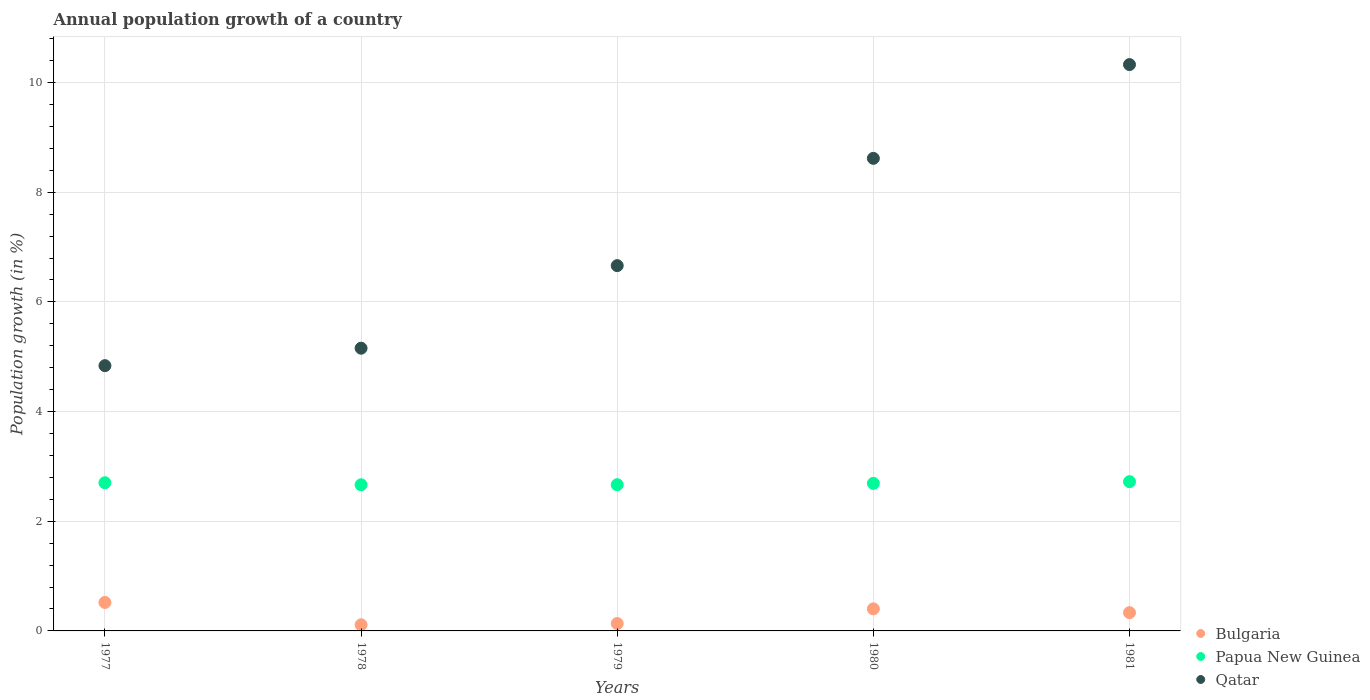Is the number of dotlines equal to the number of legend labels?
Ensure brevity in your answer.  Yes. What is the annual population growth in Qatar in 1979?
Your response must be concise. 6.66. Across all years, what is the maximum annual population growth in Papua New Guinea?
Provide a short and direct response. 2.72. Across all years, what is the minimum annual population growth in Bulgaria?
Ensure brevity in your answer.  0.11. In which year was the annual population growth in Papua New Guinea minimum?
Your answer should be compact. 1978. What is the total annual population growth in Bulgaria in the graph?
Your answer should be very brief. 1.5. What is the difference between the annual population growth in Qatar in 1977 and that in 1978?
Provide a succinct answer. -0.32. What is the difference between the annual population growth in Papua New Guinea in 1981 and the annual population growth in Bulgaria in 1977?
Your answer should be very brief. 2.2. What is the average annual population growth in Papua New Guinea per year?
Make the answer very short. 2.69. In the year 1979, what is the difference between the annual population growth in Papua New Guinea and annual population growth in Bulgaria?
Ensure brevity in your answer.  2.53. What is the ratio of the annual population growth in Papua New Guinea in 1978 to that in 1981?
Your answer should be very brief. 0.98. Is the difference between the annual population growth in Papua New Guinea in 1977 and 1979 greater than the difference between the annual population growth in Bulgaria in 1977 and 1979?
Your answer should be compact. No. What is the difference between the highest and the second highest annual population growth in Papua New Guinea?
Offer a very short reply. 0.02. What is the difference between the highest and the lowest annual population growth in Bulgaria?
Make the answer very short. 0.41. Is the sum of the annual population growth in Qatar in 1978 and 1979 greater than the maximum annual population growth in Bulgaria across all years?
Provide a short and direct response. Yes. Does the annual population growth in Bulgaria monotonically increase over the years?
Offer a very short reply. No. Is the annual population growth in Qatar strictly greater than the annual population growth in Bulgaria over the years?
Your response must be concise. Yes. Is the annual population growth in Qatar strictly less than the annual population growth in Papua New Guinea over the years?
Your answer should be compact. No. How many years are there in the graph?
Your answer should be compact. 5. Are the values on the major ticks of Y-axis written in scientific E-notation?
Provide a short and direct response. No. Does the graph contain any zero values?
Provide a succinct answer. No. Does the graph contain grids?
Provide a short and direct response. Yes. Where does the legend appear in the graph?
Keep it short and to the point. Bottom right. How are the legend labels stacked?
Offer a terse response. Vertical. What is the title of the graph?
Make the answer very short. Annual population growth of a country. Does "Mexico" appear as one of the legend labels in the graph?
Offer a very short reply. No. What is the label or title of the Y-axis?
Your answer should be very brief. Population growth (in %). What is the Population growth (in %) in Bulgaria in 1977?
Your answer should be very brief. 0.52. What is the Population growth (in %) of Papua New Guinea in 1977?
Provide a succinct answer. 2.7. What is the Population growth (in %) in Qatar in 1977?
Provide a short and direct response. 4.84. What is the Population growth (in %) of Bulgaria in 1978?
Your answer should be very brief. 0.11. What is the Population growth (in %) in Papua New Guinea in 1978?
Offer a very short reply. 2.66. What is the Population growth (in %) in Qatar in 1978?
Your response must be concise. 5.16. What is the Population growth (in %) of Bulgaria in 1979?
Your response must be concise. 0.14. What is the Population growth (in %) in Papua New Guinea in 1979?
Ensure brevity in your answer.  2.67. What is the Population growth (in %) of Qatar in 1979?
Offer a terse response. 6.66. What is the Population growth (in %) of Bulgaria in 1980?
Provide a short and direct response. 0.4. What is the Population growth (in %) in Papua New Guinea in 1980?
Your response must be concise. 2.69. What is the Population growth (in %) in Qatar in 1980?
Give a very brief answer. 8.62. What is the Population growth (in %) in Bulgaria in 1981?
Keep it short and to the point. 0.33. What is the Population growth (in %) in Papua New Guinea in 1981?
Offer a terse response. 2.72. What is the Population growth (in %) in Qatar in 1981?
Your answer should be compact. 10.33. Across all years, what is the maximum Population growth (in %) in Bulgaria?
Your answer should be very brief. 0.52. Across all years, what is the maximum Population growth (in %) in Papua New Guinea?
Offer a very short reply. 2.72. Across all years, what is the maximum Population growth (in %) of Qatar?
Offer a terse response. 10.33. Across all years, what is the minimum Population growth (in %) in Bulgaria?
Give a very brief answer. 0.11. Across all years, what is the minimum Population growth (in %) of Papua New Guinea?
Give a very brief answer. 2.66. Across all years, what is the minimum Population growth (in %) in Qatar?
Your answer should be compact. 4.84. What is the total Population growth (in %) in Bulgaria in the graph?
Offer a very short reply. 1.5. What is the total Population growth (in %) in Papua New Guinea in the graph?
Offer a terse response. 13.45. What is the total Population growth (in %) of Qatar in the graph?
Provide a succinct answer. 35.6. What is the difference between the Population growth (in %) of Bulgaria in 1977 and that in 1978?
Your response must be concise. 0.41. What is the difference between the Population growth (in %) in Papua New Guinea in 1977 and that in 1978?
Provide a succinct answer. 0.04. What is the difference between the Population growth (in %) of Qatar in 1977 and that in 1978?
Ensure brevity in your answer.  -0.32. What is the difference between the Population growth (in %) of Bulgaria in 1977 and that in 1979?
Your answer should be very brief. 0.38. What is the difference between the Population growth (in %) of Papua New Guinea in 1977 and that in 1979?
Make the answer very short. 0.04. What is the difference between the Population growth (in %) in Qatar in 1977 and that in 1979?
Offer a terse response. -1.82. What is the difference between the Population growth (in %) in Bulgaria in 1977 and that in 1980?
Keep it short and to the point. 0.12. What is the difference between the Population growth (in %) of Papua New Guinea in 1977 and that in 1980?
Provide a succinct answer. 0.01. What is the difference between the Population growth (in %) in Qatar in 1977 and that in 1980?
Make the answer very short. -3.78. What is the difference between the Population growth (in %) of Bulgaria in 1977 and that in 1981?
Give a very brief answer. 0.19. What is the difference between the Population growth (in %) of Papua New Guinea in 1977 and that in 1981?
Your answer should be very brief. -0.02. What is the difference between the Population growth (in %) of Qatar in 1977 and that in 1981?
Your answer should be compact. -5.49. What is the difference between the Population growth (in %) of Bulgaria in 1978 and that in 1979?
Your response must be concise. -0.02. What is the difference between the Population growth (in %) in Papua New Guinea in 1978 and that in 1979?
Ensure brevity in your answer.  -0. What is the difference between the Population growth (in %) of Qatar in 1978 and that in 1979?
Ensure brevity in your answer.  -1.51. What is the difference between the Population growth (in %) of Bulgaria in 1978 and that in 1980?
Offer a terse response. -0.29. What is the difference between the Population growth (in %) in Papua New Guinea in 1978 and that in 1980?
Keep it short and to the point. -0.03. What is the difference between the Population growth (in %) of Qatar in 1978 and that in 1980?
Provide a succinct answer. -3.46. What is the difference between the Population growth (in %) in Bulgaria in 1978 and that in 1981?
Your response must be concise. -0.22. What is the difference between the Population growth (in %) of Papua New Guinea in 1978 and that in 1981?
Your answer should be compact. -0.06. What is the difference between the Population growth (in %) of Qatar in 1978 and that in 1981?
Your answer should be very brief. -5.17. What is the difference between the Population growth (in %) of Bulgaria in 1979 and that in 1980?
Provide a succinct answer. -0.27. What is the difference between the Population growth (in %) in Papua New Guinea in 1979 and that in 1980?
Make the answer very short. -0.02. What is the difference between the Population growth (in %) in Qatar in 1979 and that in 1980?
Give a very brief answer. -1.96. What is the difference between the Population growth (in %) of Bulgaria in 1979 and that in 1981?
Make the answer very short. -0.2. What is the difference between the Population growth (in %) of Papua New Guinea in 1979 and that in 1981?
Your response must be concise. -0.06. What is the difference between the Population growth (in %) in Qatar in 1979 and that in 1981?
Provide a succinct answer. -3.67. What is the difference between the Population growth (in %) of Bulgaria in 1980 and that in 1981?
Provide a succinct answer. 0.07. What is the difference between the Population growth (in %) in Papua New Guinea in 1980 and that in 1981?
Provide a short and direct response. -0.03. What is the difference between the Population growth (in %) in Qatar in 1980 and that in 1981?
Your answer should be very brief. -1.71. What is the difference between the Population growth (in %) of Bulgaria in 1977 and the Population growth (in %) of Papua New Guinea in 1978?
Your response must be concise. -2.15. What is the difference between the Population growth (in %) of Bulgaria in 1977 and the Population growth (in %) of Qatar in 1978?
Your response must be concise. -4.64. What is the difference between the Population growth (in %) of Papua New Guinea in 1977 and the Population growth (in %) of Qatar in 1978?
Provide a short and direct response. -2.45. What is the difference between the Population growth (in %) in Bulgaria in 1977 and the Population growth (in %) in Papua New Guinea in 1979?
Your answer should be very brief. -2.15. What is the difference between the Population growth (in %) of Bulgaria in 1977 and the Population growth (in %) of Qatar in 1979?
Keep it short and to the point. -6.14. What is the difference between the Population growth (in %) in Papua New Guinea in 1977 and the Population growth (in %) in Qatar in 1979?
Make the answer very short. -3.96. What is the difference between the Population growth (in %) of Bulgaria in 1977 and the Population growth (in %) of Papua New Guinea in 1980?
Give a very brief answer. -2.17. What is the difference between the Population growth (in %) of Bulgaria in 1977 and the Population growth (in %) of Qatar in 1980?
Keep it short and to the point. -8.1. What is the difference between the Population growth (in %) in Papua New Guinea in 1977 and the Population growth (in %) in Qatar in 1980?
Offer a terse response. -5.92. What is the difference between the Population growth (in %) of Bulgaria in 1977 and the Population growth (in %) of Papua New Guinea in 1981?
Provide a succinct answer. -2.2. What is the difference between the Population growth (in %) in Bulgaria in 1977 and the Population growth (in %) in Qatar in 1981?
Make the answer very short. -9.81. What is the difference between the Population growth (in %) of Papua New Guinea in 1977 and the Population growth (in %) of Qatar in 1981?
Give a very brief answer. -7.62. What is the difference between the Population growth (in %) of Bulgaria in 1978 and the Population growth (in %) of Papua New Guinea in 1979?
Provide a short and direct response. -2.55. What is the difference between the Population growth (in %) in Bulgaria in 1978 and the Population growth (in %) in Qatar in 1979?
Make the answer very short. -6.55. What is the difference between the Population growth (in %) in Papua New Guinea in 1978 and the Population growth (in %) in Qatar in 1979?
Your answer should be very brief. -4. What is the difference between the Population growth (in %) of Bulgaria in 1978 and the Population growth (in %) of Papua New Guinea in 1980?
Your answer should be very brief. -2.58. What is the difference between the Population growth (in %) in Bulgaria in 1978 and the Population growth (in %) in Qatar in 1980?
Make the answer very short. -8.51. What is the difference between the Population growth (in %) in Papua New Guinea in 1978 and the Population growth (in %) in Qatar in 1980?
Give a very brief answer. -5.95. What is the difference between the Population growth (in %) of Bulgaria in 1978 and the Population growth (in %) of Papua New Guinea in 1981?
Your response must be concise. -2.61. What is the difference between the Population growth (in %) in Bulgaria in 1978 and the Population growth (in %) in Qatar in 1981?
Give a very brief answer. -10.22. What is the difference between the Population growth (in %) of Papua New Guinea in 1978 and the Population growth (in %) of Qatar in 1981?
Your answer should be compact. -7.66. What is the difference between the Population growth (in %) of Bulgaria in 1979 and the Population growth (in %) of Papua New Guinea in 1980?
Offer a terse response. -2.56. What is the difference between the Population growth (in %) of Bulgaria in 1979 and the Population growth (in %) of Qatar in 1980?
Keep it short and to the point. -8.48. What is the difference between the Population growth (in %) in Papua New Guinea in 1979 and the Population growth (in %) in Qatar in 1980?
Your response must be concise. -5.95. What is the difference between the Population growth (in %) in Bulgaria in 1979 and the Population growth (in %) in Papua New Guinea in 1981?
Your response must be concise. -2.59. What is the difference between the Population growth (in %) of Bulgaria in 1979 and the Population growth (in %) of Qatar in 1981?
Give a very brief answer. -10.19. What is the difference between the Population growth (in %) of Papua New Guinea in 1979 and the Population growth (in %) of Qatar in 1981?
Your answer should be compact. -7.66. What is the difference between the Population growth (in %) of Bulgaria in 1980 and the Population growth (in %) of Papua New Guinea in 1981?
Your answer should be compact. -2.32. What is the difference between the Population growth (in %) of Bulgaria in 1980 and the Population growth (in %) of Qatar in 1981?
Provide a succinct answer. -9.92. What is the difference between the Population growth (in %) of Papua New Guinea in 1980 and the Population growth (in %) of Qatar in 1981?
Provide a short and direct response. -7.64. What is the average Population growth (in %) of Bulgaria per year?
Give a very brief answer. 0.3. What is the average Population growth (in %) in Papua New Guinea per year?
Provide a succinct answer. 2.69. What is the average Population growth (in %) of Qatar per year?
Offer a terse response. 7.12. In the year 1977, what is the difference between the Population growth (in %) in Bulgaria and Population growth (in %) in Papua New Guinea?
Provide a succinct answer. -2.18. In the year 1977, what is the difference between the Population growth (in %) in Bulgaria and Population growth (in %) in Qatar?
Provide a short and direct response. -4.32. In the year 1977, what is the difference between the Population growth (in %) of Papua New Guinea and Population growth (in %) of Qatar?
Give a very brief answer. -2.13. In the year 1978, what is the difference between the Population growth (in %) of Bulgaria and Population growth (in %) of Papua New Guinea?
Give a very brief answer. -2.55. In the year 1978, what is the difference between the Population growth (in %) in Bulgaria and Population growth (in %) in Qatar?
Ensure brevity in your answer.  -5.04. In the year 1978, what is the difference between the Population growth (in %) in Papua New Guinea and Population growth (in %) in Qatar?
Give a very brief answer. -2.49. In the year 1979, what is the difference between the Population growth (in %) of Bulgaria and Population growth (in %) of Papua New Guinea?
Keep it short and to the point. -2.53. In the year 1979, what is the difference between the Population growth (in %) of Bulgaria and Population growth (in %) of Qatar?
Give a very brief answer. -6.53. In the year 1979, what is the difference between the Population growth (in %) in Papua New Guinea and Population growth (in %) in Qatar?
Your answer should be compact. -3.99. In the year 1980, what is the difference between the Population growth (in %) in Bulgaria and Population growth (in %) in Papua New Guinea?
Offer a very short reply. -2.29. In the year 1980, what is the difference between the Population growth (in %) in Bulgaria and Population growth (in %) in Qatar?
Your answer should be very brief. -8.21. In the year 1980, what is the difference between the Population growth (in %) in Papua New Guinea and Population growth (in %) in Qatar?
Offer a terse response. -5.93. In the year 1981, what is the difference between the Population growth (in %) in Bulgaria and Population growth (in %) in Papua New Guinea?
Offer a very short reply. -2.39. In the year 1981, what is the difference between the Population growth (in %) of Bulgaria and Population growth (in %) of Qatar?
Provide a succinct answer. -9.99. In the year 1981, what is the difference between the Population growth (in %) of Papua New Guinea and Population growth (in %) of Qatar?
Your answer should be very brief. -7.61. What is the ratio of the Population growth (in %) of Bulgaria in 1977 to that in 1978?
Your response must be concise. 4.64. What is the ratio of the Population growth (in %) of Papua New Guinea in 1977 to that in 1978?
Offer a very short reply. 1.01. What is the ratio of the Population growth (in %) in Qatar in 1977 to that in 1978?
Your response must be concise. 0.94. What is the ratio of the Population growth (in %) in Bulgaria in 1977 to that in 1979?
Provide a succinct answer. 3.84. What is the ratio of the Population growth (in %) in Papua New Guinea in 1977 to that in 1979?
Your response must be concise. 1.01. What is the ratio of the Population growth (in %) in Qatar in 1977 to that in 1979?
Keep it short and to the point. 0.73. What is the ratio of the Population growth (in %) in Bulgaria in 1977 to that in 1980?
Provide a short and direct response. 1.29. What is the ratio of the Population growth (in %) in Qatar in 1977 to that in 1980?
Provide a succinct answer. 0.56. What is the ratio of the Population growth (in %) of Bulgaria in 1977 to that in 1981?
Offer a very short reply. 1.56. What is the ratio of the Population growth (in %) in Papua New Guinea in 1977 to that in 1981?
Give a very brief answer. 0.99. What is the ratio of the Population growth (in %) in Qatar in 1977 to that in 1981?
Offer a terse response. 0.47. What is the ratio of the Population growth (in %) of Bulgaria in 1978 to that in 1979?
Offer a very short reply. 0.83. What is the ratio of the Population growth (in %) of Qatar in 1978 to that in 1979?
Provide a succinct answer. 0.77. What is the ratio of the Population growth (in %) of Bulgaria in 1978 to that in 1980?
Offer a terse response. 0.28. What is the ratio of the Population growth (in %) in Qatar in 1978 to that in 1980?
Your answer should be compact. 0.6. What is the ratio of the Population growth (in %) of Bulgaria in 1978 to that in 1981?
Provide a succinct answer. 0.34. What is the ratio of the Population growth (in %) in Papua New Guinea in 1978 to that in 1981?
Your answer should be compact. 0.98. What is the ratio of the Population growth (in %) of Qatar in 1978 to that in 1981?
Make the answer very short. 0.5. What is the ratio of the Population growth (in %) in Bulgaria in 1979 to that in 1980?
Your response must be concise. 0.34. What is the ratio of the Population growth (in %) in Papua New Guinea in 1979 to that in 1980?
Offer a very short reply. 0.99. What is the ratio of the Population growth (in %) in Qatar in 1979 to that in 1980?
Your answer should be very brief. 0.77. What is the ratio of the Population growth (in %) of Bulgaria in 1979 to that in 1981?
Your response must be concise. 0.41. What is the ratio of the Population growth (in %) in Papua New Guinea in 1979 to that in 1981?
Offer a terse response. 0.98. What is the ratio of the Population growth (in %) of Qatar in 1979 to that in 1981?
Your answer should be compact. 0.65. What is the ratio of the Population growth (in %) of Bulgaria in 1980 to that in 1981?
Provide a succinct answer. 1.21. What is the ratio of the Population growth (in %) of Papua New Guinea in 1980 to that in 1981?
Your answer should be compact. 0.99. What is the ratio of the Population growth (in %) in Qatar in 1980 to that in 1981?
Offer a terse response. 0.83. What is the difference between the highest and the second highest Population growth (in %) in Bulgaria?
Offer a terse response. 0.12. What is the difference between the highest and the second highest Population growth (in %) in Papua New Guinea?
Your response must be concise. 0.02. What is the difference between the highest and the second highest Population growth (in %) in Qatar?
Your response must be concise. 1.71. What is the difference between the highest and the lowest Population growth (in %) of Bulgaria?
Provide a short and direct response. 0.41. What is the difference between the highest and the lowest Population growth (in %) in Papua New Guinea?
Offer a very short reply. 0.06. What is the difference between the highest and the lowest Population growth (in %) of Qatar?
Your answer should be very brief. 5.49. 